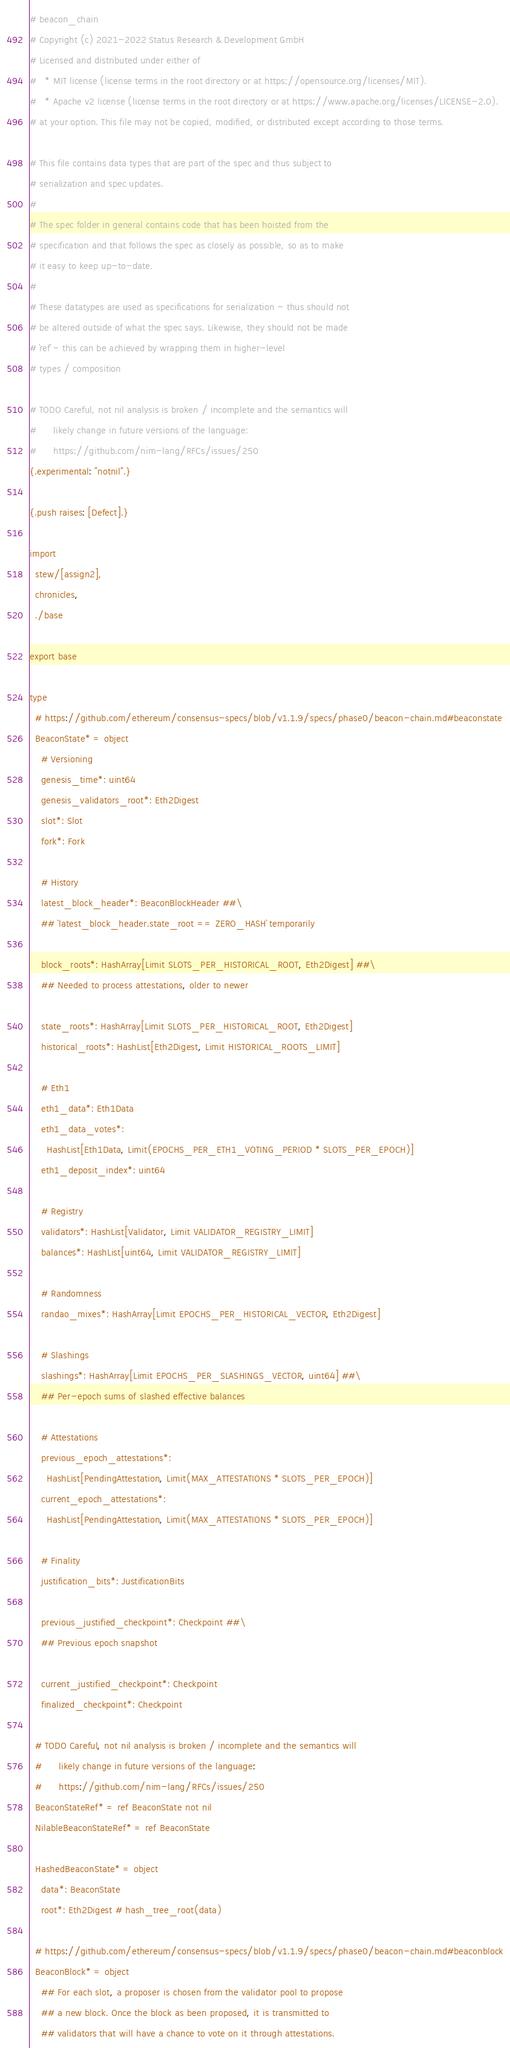<code> <loc_0><loc_0><loc_500><loc_500><_Nim_># beacon_chain
# Copyright (c) 2021-2022 Status Research & Development GmbH
# Licensed and distributed under either of
#   * MIT license (license terms in the root directory or at https://opensource.org/licenses/MIT).
#   * Apache v2 license (license terms in the root directory or at https://www.apache.org/licenses/LICENSE-2.0).
# at your option. This file may not be copied, modified, or distributed except according to those terms.

# This file contains data types that are part of the spec and thus subject to
# serialization and spec updates.
#
# The spec folder in general contains code that has been hoisted from the
# specification and that follows the spec as closely as possible, so as to make
# it easy to keep up-to-date.
#
# These datatypes are used as specifications for serialization - thus should not
# be altered outside of what the spec says. Likewise, they should not be made
# `ref` - this can be achieved by wrapping them in higher-level
# types / composition

# TODO Careful, not nil analysis is broken / incomplete and the semantics will
#      likely change in future versions of the language:
#      https://github.com/nim-lang/RFCs/issues/250
{.experimental: "notnil".}

{.push raises: [Defect].}

import
  stew/[assign2],
  chronicles,
  ./base

export base

type
  # https://github.com/ethereum/consensus-specs/blob/v1.1.9/specs/phase0/beacon-chain.md#beaconstate
  BeaconState* = object
    # Versioning
    genesis_time*: uint64
    genesis_validators_root*: Eth2Digest
    slot*: Slot
    fork*: Fork

    # History
    latest_block_header*: BeaconBlockHeader ##\
    ## `latest_block_header.state_root == ZERO_HASH` temporarily

    block_roots*: HashArray[Limit SLOTS_PER_HISTORICAL_ROOT, Eth2Digest] ##\
    ## Needed to process attestations, older to newer

    state_roots*: HashArray[Limit SLOTS_PER_HISTORICAL_ROOT, Eth2Digest]
    historical_roots*: HashList[Eth2Digest, Limit HISTORICAL_ROOTS_LIMIT]

    # Eth1
    eth1_data*: Eth1Data
    eth1_data_votes*:
      HashList[Eth1Data, Limit(EPOCHS_PER_ETH1_VOTING_PERIOD * SLOTS_PER_EPOCH)]
    eth1_deposit_index*: uint64

    # Registry
    validators*: HashList[Validator, Limit VALIDATOR_REGISTRY_LIMIT]
    balances*: HashList[uint64, Limit VALIDATOR_REGISTRY_LIMIT]

    # Randomness
    randao_mixes*: HashArray[Limit EPOCHS_PER_HISTORICAL_VECTOR, Eth2Digest]

    # Slashings
    slashings*: HashArray[Limit EPOCHS_PER_SLASHINGS_VECTOR, uint64] ##\
    ## Per-epoch sums of slashed effective balances

    # Attestations
    previous_epoch_attestations*:
      HashList[PendingAttestation, Limit(MAX_ATTESTATIONS * SLOTS_PER_EPOCH)]
    current_epoch_attestations*:
      HashList[PendingAttestation, Limit(MAX_ATTESTATIONS * SLOTS_PER_EPOCH)]

    # Finality
    justification_bits*: JustificationBits

    previous_justified_checkpoint*: Checkpoint ##\
    ## Previous epoch snapshot

    current_justified_checkpoint*: Checkpoint
    finalized_checkpoint*: Checkpoint

  # TODO Careful, not nil analysis is broken / incomplete and the semantics will
  #      likely change in future versions of the language:
  #      https://github.com/nim-lang/RFCs/issues/250
  BeaconStateRef* = ref BeaconState not nil
  NilableBeaconStateRef* = ref BeaconState

  HashedBeaconState* = object
    data*: BeaconState
    root*: Eth2Digest # hash_tree_root(data)

  # https://github.com/ethereum/consensus-specs/blob/v1.1.9/specs/phase0/beacon-chain.md#beaconblock
  BeaconBlock* = object
    ## For each slot, a proposer is chosen from the validator pool to propose
    ## a new block. Once the block as been proposed, it is transmitted to
    ## validators that will have a chance to vote on it through attestations.</code> 